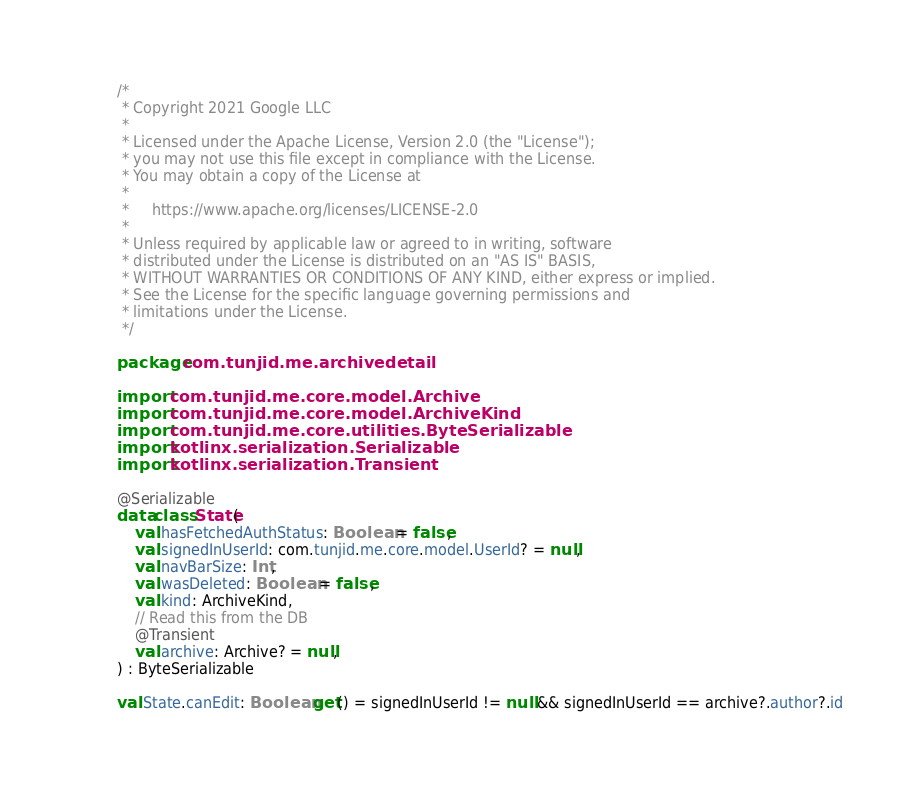Convert code to text. <code><loc_0><loc_0><loc_500><loc_500><_Kotlin_>/*
 * Copyright 2021 Google LLC
 *
 * Licensed under the Apache License, Version 2.0 (the "License");
 * you may not use this file except in compliance with the License.
 * You may obtain a copy of the License at
 *
 *     https://www.apache.org/licenses/LICENSE-2.0
 *
 * Unless required by applicable law or agreed to in writing, software
 * distributed under the License is distributed on an "AS IS" BASIS,
 * WITHOUT WARRANTIES OR CONDITIONS OF ANY KIND, either express or implied.
 * See the License for the specific language governing permissions and
 * limitations under the License.
 */

package com.tunjid.me.archivedetail

import com.tunjid.me.core.model.Archive
import com.tunjid.me.core.model.ArchiveKind
import com.tunjid.me.core.utilities.ByteSerializable
import kotlinx.serialization.Serializable
import kotlinx.serialization.Transient

@Serializable
data class State(
    val hasFetchedAuthStatus: Boolean = false,
    val signedInUserId: com.tunjid.me.core.model.UserId? = null,
    val navBarSize: Int,
    val wasDeleted: Boolean = false,
    val kind: ArchiveKind,
    // Read this from the DB
    @Transient
    val archive: Archive? = null,
) : ByteSerializable

val State.canEdit: Boolean get() = signedInUserId != null && signedInUserId == archive?.author?.id</code> 